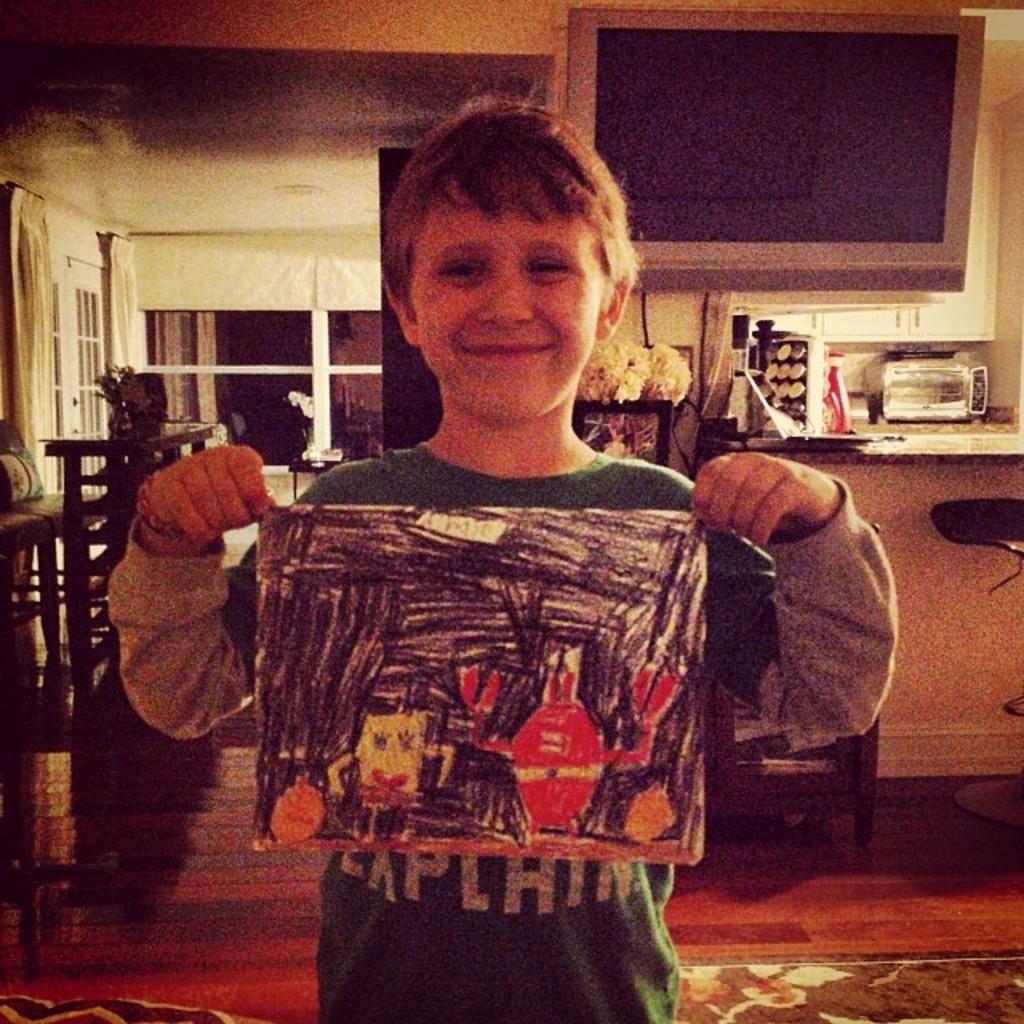Could you give a brief overview of what you see in this image? This picture is clicked inside the room. The boy in green T-shirt is holding a paper containing painting in his hands. He is smiling. Behind him, we see a television and a table on which things are placed. Beside that, we see a flower vase. On the left side, we see a table on which flower vase is placed. In the background, we see windows and curtains. In the left top of the picture, we see the ceiling of the room. 